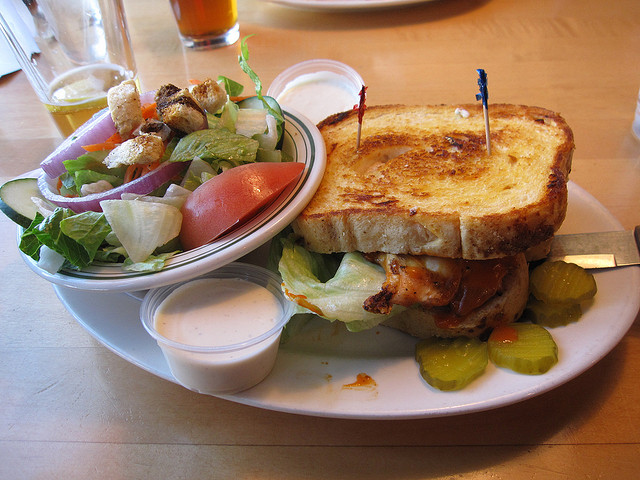What brand of beer is on the table? I can't see any specific beer brand on the table based on the image, as it is not directly visible or clear enough to identify. 